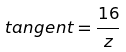<formula> <loc_0><loc_0><loc_500><loc_500>t a n g e n t = \frac { 1 6 } { z }</formula> 